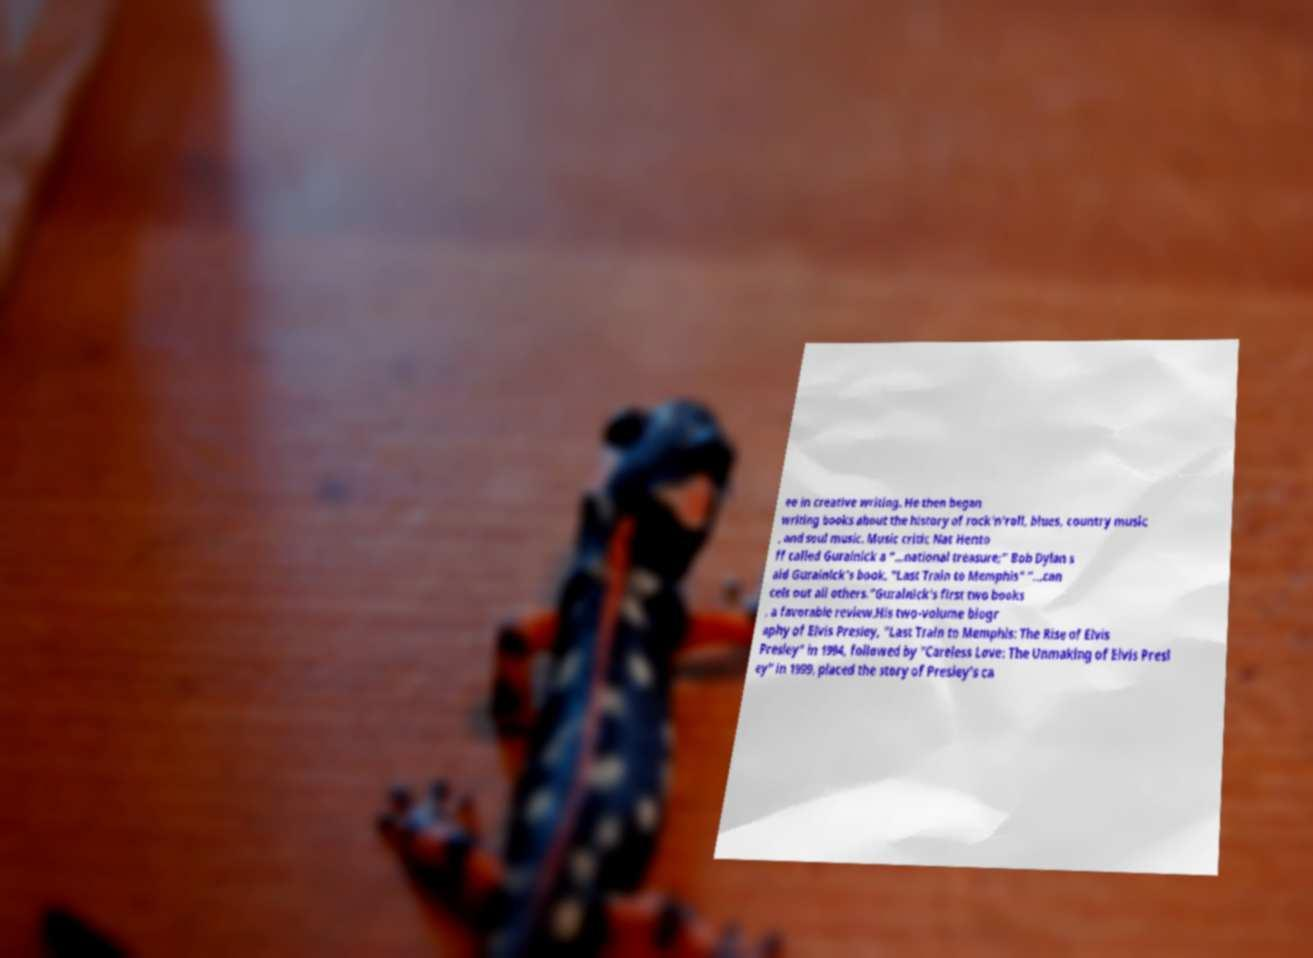Please read and relay the text visible in this image. What does it say? ee in creative writing. He then began writing books about the history of rock'n'roll, blues, country music , and soul music. Music critic Nat Hento ff called Guralnick a “…national treasure;” Bob Dylan s aid Guralnick’s book, "Last Train to Memphis" “…can cels out all others.”Guralnick's first two books , a favorable review.His two-volume biogr aphy of Elvis Presley, "Last Train to Memphis: The Rise of Elvis Presley" in 1994, followed by "Careless Love: The Unmaking of Elvis Presl ey" in 1999, placed the story of Presley's ca 